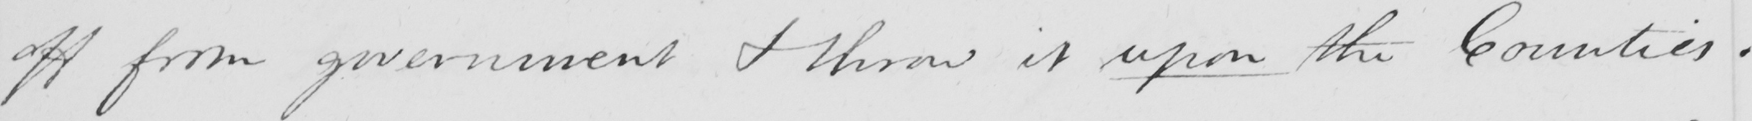What is written in this line of handwriting? off from government & throw them upon the Counties . 